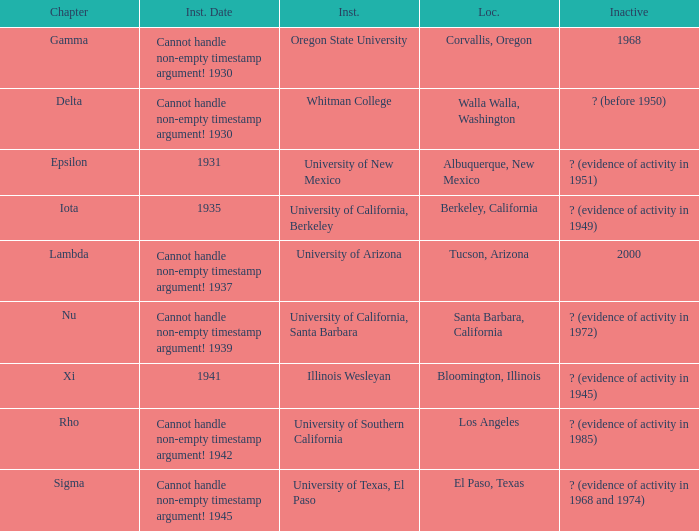What was the installation date in El Paso, Texas?  Cannot handle non-empty timestamp argument! 1945. 